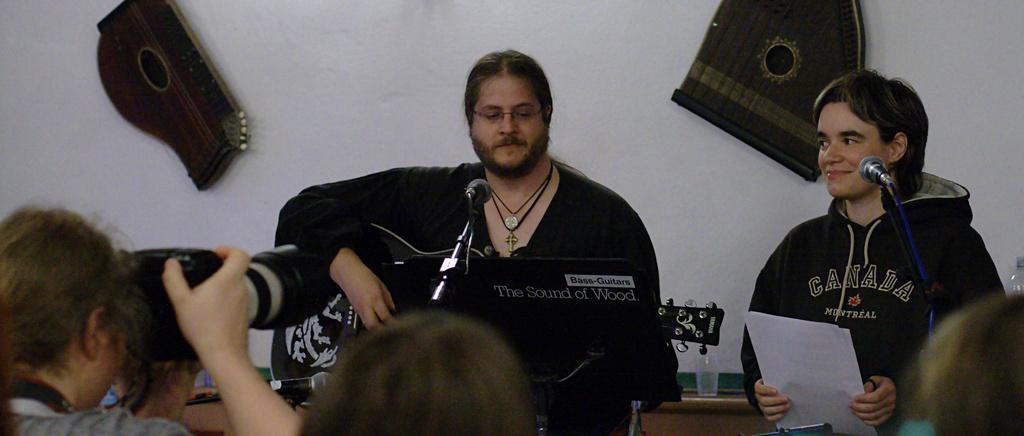Could you give a brief overview of what you see in this image? In this picture there are persons standing. The man in the center is holding a musical instrument in his hand and smiling in front of the man there is a mic. On the right side there is a person standing and holding a paper and in front of the person there is a mic, and the person is smiling. In the front on the left side there is a person holding a camera and clicking a photo. In the background on the wall there are objects hanging. In front of the wall there is a glass on the table and the wall is white in colour. 